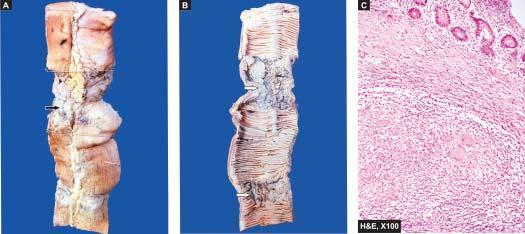what is thickened?
Answer the question using a single word or phrase. Wall of intestine in the area of narrowed lumen 